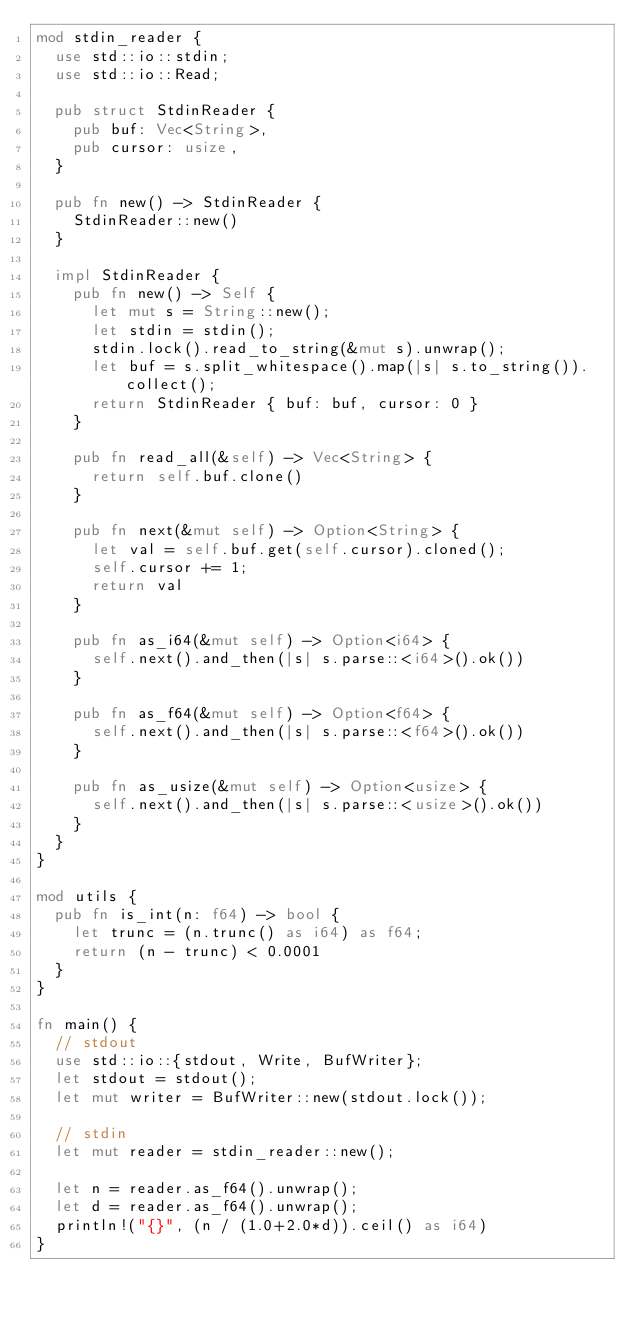Convert code to text. <code><loc_0><loc_0><loc_500><loc_500><_Rust_>mod stdin_reader {
  use std::io::stdin;
  use std::io::Read;

  pub struct StdinReader {
    pub buf: Vec<String>,
    pub cursor: usize,
  }

  pub fn new() -> StdinReader {
    StdinReader::new()
  }

  impl StdinReader {
    pub fn new() -> Self {
      let mut s = String::new();
      let stdin = stdin();
      stdin.lock().read_to_string(&mut s).unwrap();
      let buf = s.split_whitespace().map(|s| s.to_string()).collect();
      return StdinReader { buf: buf, cursor: 0 }
    }

    pub fn read_all(&self) -> Vec<String> {
      return self.buf.clone()
    }

    pub fn next(&mut self) -> Option<String> {
      let val = self.buf.get(self.cursor).cloned();
      self.cursor += 1;
      return val
    }

    pub fn as_i64(&mut self) -> Option<i64> {
      self.next().and_then(|s| s.parse::<i64>().ok())
    }

    pub fn as_f64(&mut self) -> Option<f64> {
      self.next().and_then(|s| s.parse::<f64>().ok())
    }

    pub fn as_usize(&mut self) -> Option<usize> {
      self.next().and_then(|s| s.parse::<usize>().ok())
    }
  }
}

mod utils {
  pub fn is_int(n: f64) -> bool {
    let trunc = (n.trunc() as i64) as f64;
    return (n - trunc) < 0.0001
  }
}

fn main() {
  // stdout
  use std::io::{stdout, Write, BufWriter};
  let stdout = stdout();
  let mut writer = BufWriter::new(stdout.lock());

  // stdin
  let mut reader = stdin_reader::new();

  let n = reader.as_f64().unwrap();
  let d = reader.as_f64().unwrap();
  println!("{}", (n / (1.0+2.0*d)).ceil() as i64)
}</code> 